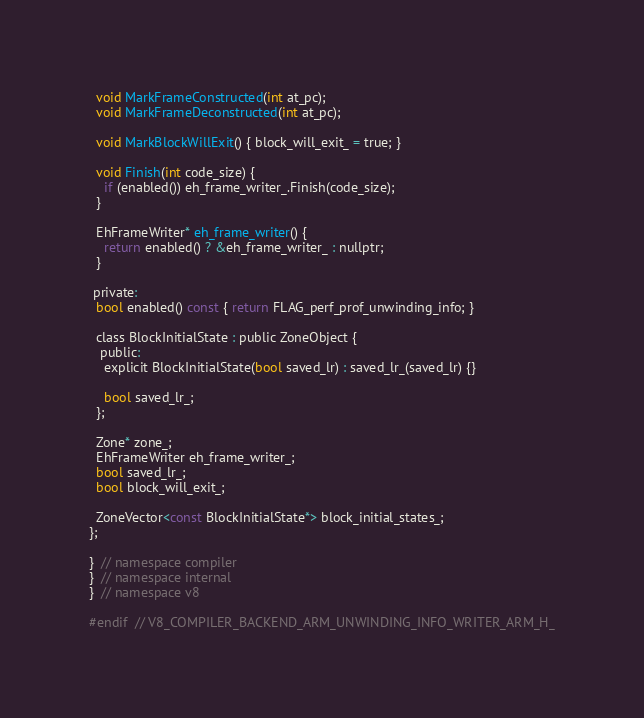<code> <loc_0><loc_0><loc_500><loc_500><_C_>
  void MarkFrameConstructed(int at_pc);
  void MarkFrameDeconstructed(int at_pc);

  void MarkBlockWillExit() { block_will_exit_ = true; }

  void Finish(int code_size) {
    if (enabled()) eh_frame_writer_.Finish(code_size);
  }

  EhFrameWriter* eh_frame_writer() {
    return enabled() ? &eh_frame_writer_ : nullptr;
  }

 private:
  bool enabled() const { return FLAG_perf_prof_unwinding_info; }

  class BlockInitialState : public ZoneObject {
   public:
    explicit BlockInitialState(bool saved_lr) : saved_lr_(saved_lr) {}

    bool saved_lr_;
  };

  Zone* zone_;
  EhFrameWriter eh_frame_writer_;
  bool saved_lr_;
  bool block_will_exit_;

  ZoneVector<const BlockInitialState*> block_initial_states_;
};

}  // namespace compiler
}  // namespace internal
}  // namespace v8

#endif  // V8_COMPILER_BACKEND_ARM_UNWINDING_INFO_WRITER_ARM_H_
</code> 